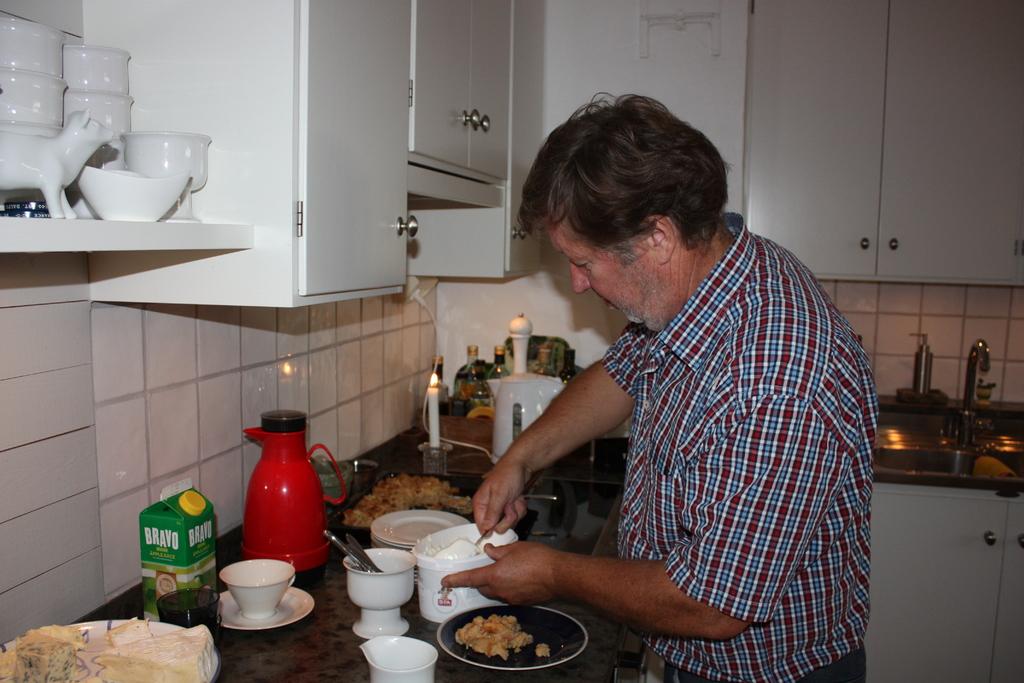What does the green container say?
Ensure brevity in your answer.  Bravo. 